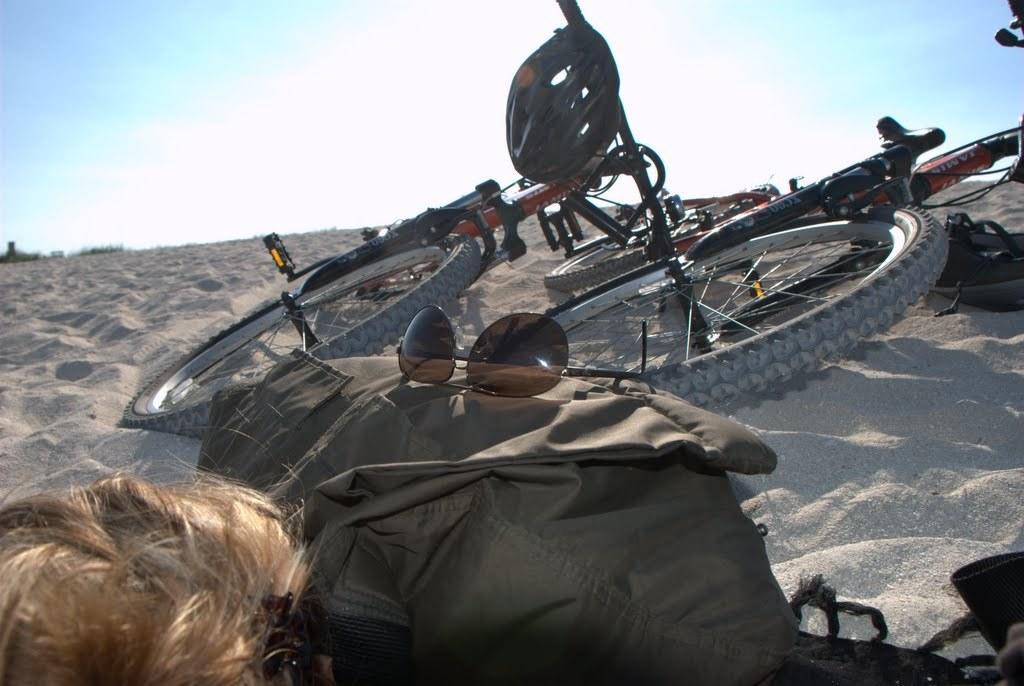In one or two sentences, can you explain what this image depicts? In this picture we can see a person, in front of the person we can find baggage, spectacles, bicycles and a helmet. 